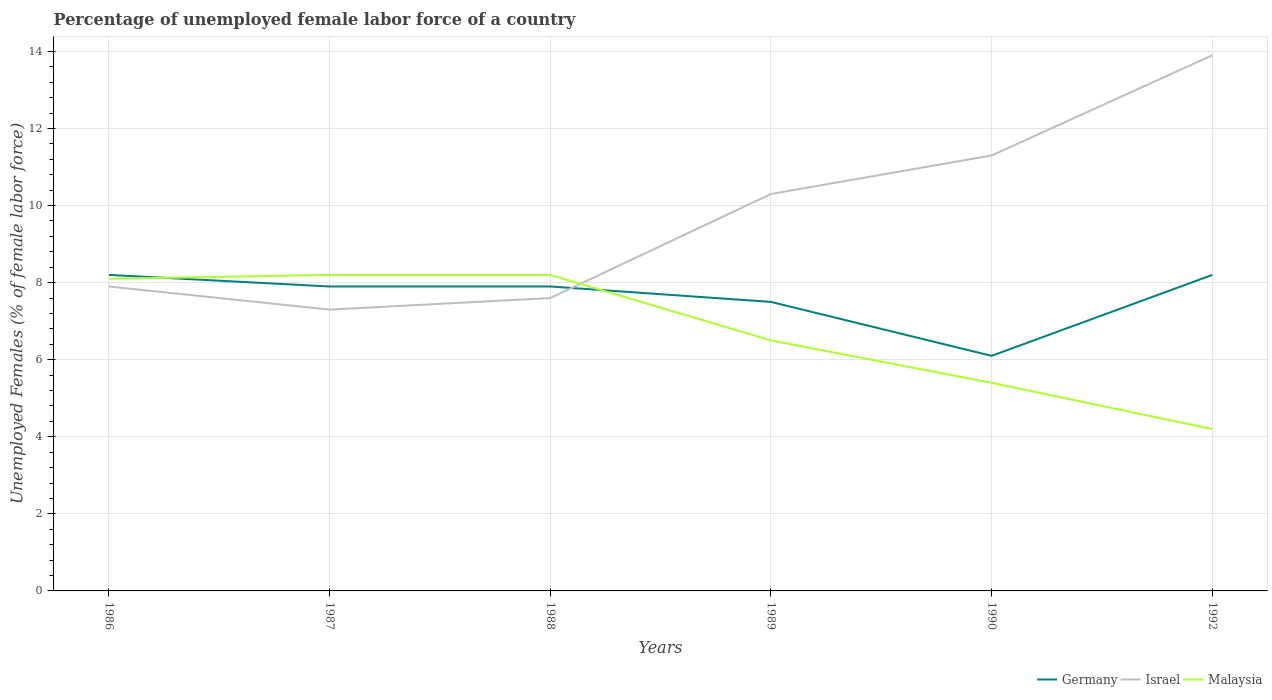Does the line corresponding to Israel intersect with the line corresponding to Germany?
Your response must be concise. Yes. Across all years, what is the maximum percentage of unemployed female labor force in Israel?
Make the answer very short. 7.3. In which year was the percentage of unemployed female labor force in Israel maximum?
Your answer should be compact. 1987. What is the total percentage of unemployed female labor force in Malaysia in the graph?
Provide a succinct answer. 1.7. What is the difference between the highest and the second highest percentage of unemployed female labor force in Israel?
Provide a succinct answer. 6.6. Is the percentage of unemployed female labor force in Israel strictly greater than the percentage of unemployed female labor force in Germany over the years?
Make the answer very short. No. How many lines are there?
Make the answer very short. 3. Are the values on the major ticks of Y-axis written in scientific E-notation?
Provide a short and direct response. No. Does the graph contain grids?
Your response must be concise. Yes. Where does the legend appear in the graph?
Offer a terse response. Bottom right. How many legend labels are there?
Give a very brief answer. 3. What is the title of the graph?
Your answer should be compact. Percentage of unemployed female labor force of a country. What is the label or title of the X-axis?
Ensure brevity in your answer.  Years. What is the label or title of the Y-axis?
Offer a terse response. Unemployed Females (% of female labor force). What is the Unemployed Females (% of female labor force) in Germany in 1986?
Offer a very short reply. 8.2. What is the Unemployed Females (% of female labor force) in Israel in 1986?
Your answer should be very brief. 7.9. What is the Unemployed Females (% of female labor force) in Malaysia in 1986?
Give a very brief answer. 8.1. What is the Unemployed Females (% of female labor force) in Germany in 1987?
Offer a very short reply. 7.9. What is the Unemployed Females (% of female labor force) in Israel in 1987?
Your answer should be very brief. 7.3. What is the Unemployed Females (% of female labor force) of Malaysia in 1987?
Your response must be concise. 8.2. What is the Unemployed Females (% of female labor force) of Germany in 1988?
Your response must be concise. 7.9. What is the Unemployed Females (% of female labor force) of Israel in 1988?
Provide a succinct answer. 7.6. What is the Unemployed Females (% of female labor force) of Malaysia in 1988?
Provide a succinct answer. 8.2. What is the Unemployed Females (% of female labor force) in Israel in 1989?
Provide a short and direct response. 10.3. What is the Unemployed Females (% of female labor force) of Germany in 1990?
Provide a succinct answer. 6.1. What is the Unemployed Females (% of female labor force) of Israel in 1990?
Keep it short and to the point. 11.3. What is the Unemployed Females (% of female labor force) in Malaysia in 1990?
Make the answer very short. 5.4. What is the Unemployed Females (% of female labor force) in Germany in 1992?
Give a very brief answer. 8.2. What is the Unemployed Females (% of female labor force) in Israel in 1992?
Ensure brevity in your answer.  13.9. What is the Unemployed Females (% of female labor force) of Malaysia in 1992?
Your answer should be compact. 4.2. Across all years, what is the maximum Unemployed Females (% of female labor force) of Germany?
Your response must be concise. 8.2. Across all years, what is the maximum Unemployed Females (% of female labor force) in Israel?
Your answer should be very brief. 13.9. Across all years, what is the maximum Unemployed Females (% of female labor force) of Malaysia?
Provide a succinct answer. 8.2. Across all years, what is the minimum Unemployed Females (% of female labor force) of Germany?
Offer a terse response. 6.1. Across all years, what is the minimum Unemployed Females (% of female labor force) of Israel?
Give a very brief answer. 7.3. Across all years, what is the minimum Unemployed Females (% of female labor force) in Malaysia?
Offer a very short reply. 4.2. What is the total Unemployed Females (% of female labor force) in Germany in the graph?
Your answer should be compact. 45.8. What is the total Unemployed Females (% of female labor force) of Israel in the graph?
Give a very brief answer. 58.3. What is the total Unemployed Females (% of female labor force) in Malaysia in the graph?
Your answer should be very brief. 40.6. What is the difference between the Unemployed Females (% of female labor force) in Germany in 1986 and that in 1987?
Make the answer very short. 0.3. What is the difference between the Unemployed Females (% of female labor force) of Israel in 1986 and that in 1987?
Your answer should be compact. 0.6. What is the difference between the Unemployed Females (% of female labor force) in Malaysia in 1986 and that in 1988?
Provide a short and direct response. -0.1. What is the difference between the Unemployed Females (% of female labor force) in Israel in 1986 and that in 1989?
Provide a short and direct response. -2.4. What is the difference between the Unemployed Females (% of female labor force) of Germany in 1986 and that in 1990?
Ensure brevity in your answer.  2.1. What is the difference between the Unemployed Females (% of female labor force) of Israel in 1986 and that in 1990?
Provide a short and direct response. -3.4. What is the difference between the Unemployed Females (% of female labor force) of Malaysia in 1986 and that in 1990?
Provide a short and direct response. 2.7. What is the difference between the Unemployed Females (% of female labor force) in Germany in 1986 and that in 1992?
Ensure brevity in your answer.  0. What is the difference between the Unemployed Females (% of female labor force) in Germany in 1987 and that in 1988?
Keep it short and to the point. 0. What is the difference between the Unemployed Females (% of female labor force) of Israel in 1987 and that in 1988?
Your response must be concise. -0.3. What is the difference between the Unemployed Females (% of female labor force) of Malaysia in 1987 and that in 1989?
Make the answer very short. 1.7. What is the difference between the Unemployed Females (% of female labor force) of Malaysia in 1987 and that in 1990?
Offer a terse response. 2.8. What is the difference between the Unemployed Females (% of female labor force) of Germany in 1987 and that in 1992?
Your answer should be compact. -0.3. What is the difference between the Unemployed Females (% of female labor force) of Malaysia in 1987 and that in 1992?
Give a very brief answer. 4. What is the difference between the Unemployed Females (% of female labor force) of Germany in 1988 and that in 1989?
Your answer should be very brief. 0.4. What is the difference between the Unemployed Females (% of female labor force) in Malaysia in 1988 and that in 1989?
Provide a succinct answer. 1.7. What is the difference between the Unemployed Females (% of female labor force) of Germany in 1988 and that in 1990?
Provide a succinct answer. 1.8. What is the difference between the Unemployed Females (% of female labor force) of Israel in 1988 and that in 1990?
Give a very brief answer. -3.7. What is the difference between the Unemployed Females (% of female labor force) of Malaysia in 1988 and that in 1990?
Provide a succinct answer. 2.8. What is the difference between the Unemployed Females (% of female labor force) in Germany in 1988 and that in 1992?
Give a very brief answer. -0.3. What is the difference between the Unemployed Females (% of female labor force) of Israel in 1988 and that in 1992?
Provide a succinct answer. -6.3. What is the difference between the Unemployed Females (% of female labor force) of Israel in 1989 and that in 1992?
Offer a terse response. -3.6. What is the difference between the Unemployed Females (% of female labor force) in Malaysia in 1989 and that in 1992?
Make the answer very short. 2.3. What is the difference between the Unemployed Females (% of female labor force) in Germany in 1990 and that in 1992?
Offer a very short reply. -2.1. What is the difference between the Unemployed Females (% of female labor force) in Israel in 1990 and that in 1992?
Ensure brevity in your answer.  -2.6. What is the difference between the Unemployed Females (% of female labor force) of Germany in 1986 and the Unemployed Females (% of female labor force) of Israel in 1987?
Make the answer very short. 0.9. What is the difference between the Unemployed Females (% of female labor force) in Germany in 1986 and the Unemployed Females (% of female labor force) in Malaysia in 1987?
Your response must be concise. 0. What is the difference between the Unemployed Females (% of female labor force) in Germany in 1986 and the Unemployed Females (% of female labor force) in Israel in 1988?
Offer a very short reply. 0.6. What is the difference between the Unemployed Females (% of female labor force) in Germany in 1986 and the Unemployed Females (% of female labor force) in Malaysia in 1988?
Make the answer very short. 0. What is the difference between the Unemployed Females (% of female labor force) in Israel in 1986 and the Unemployed Females (% of female labor force) in Malaysia in 1988?
Provide a succinct answer. -0.3. What is the difference between the Unemployed Females (% of female labor force) of Germany in 1986 and the Unemployed Females (% of female labor force) of Israel in 1989?
Your response must be concise. -2.1. What is the difference between the Unemployed Females (% of female labor force) in Germany in 1986 and the Unemployed Females (% of female labor force) in Israel in 1990?
Provide a short and direct response. -3.1. What is the difference between the Unemployed Females (% of female labor force) in Germany in 1986 and the Unemployed Females (% of female labor force) in Malaysia in 1990?
Make the answer very short. 2.8. What is the difference between the Unemployed Females (% of female labor force) of Israel in 1986 and the Unemployed Females (% of female labor force) of Malaysia in 1992?
Offer a terse response. 3.7. What is the difference between the Unemployed Females (% of female labor force) of Germany in 1987 and the Unemployed Females (% of female labor force) of Israel in 1988?
Your response must be concise. 0.3. What is the difference between the Unemployed Females (% of female labor force) in Israel in 1987 and the Unemployed Females (% of female labor force) in Malaysia in 1988?
Provide a succinct answer. -0.9. What is the difference between the Unemployed Females (% of female labor force) in Germany in 1987 and the Unemployed Females (% of female labor force) in Israel in 1989?
Provide a succinct answer. -2.4. What is the difference between the Unemployed Females (% of female labor force) of Israel in 1987 and the Unemployed Females (% of female labor force) of Malaysia in 1989?
Give a very brief answer. 0.8. What is the difference between the Unemployed Females (% of female labor force) in Germany in 1987 and the Unemployed Females (% of female labor force) in Israel in 1990?
Your response must be concise. -3.4. What is the difference between the Unemployed Females (% of female labor force) of Germany in 1987 and the Unemployed Females (% of female labor force) of Malaysia in 1992?
Make the answer very short. 3.7. What is the difference between the Unemployed Females (% of female labor force) of Israel in 1987 and the Unemployed Females (% of female labor force) of Malaysia in 1992?
Your response must be concise. 3.1. What is the difference between the Unemployed Females (% of female labor force) in Israel in 1988 and the Unemployed Females (% of female labor force) in Malaysia in 1990?
Provide a short and direct response. 2.2. What is the difference between the Unemployed Females (% of female labor force) of Germany in 1988 and the Unemployed Females (% of female labor force) of Israel in 1992?
Your answer should be compact. -6. What is the difference between the Unemployed Females (% of female labor force) in Germany in 1988 and the Unemployed Females (% of female labor force) in Malaysia in 1992?
Your response must be concise. 3.7. What is the difference between the Unemployed Females (% of female labor force) of Germany in 1989 and the Unemployed Females (% of female labor force) of Israel in 1990?
Keep it short and to the point. -3.8. What is the difference between the Unemployed Females (% of female labor force) of Israel in 1989 and the Unemployed Females (% of female labor force) of Malaysia in 1992?
Make the answer very short. 6.1. What is the difference between the Unemployed Females (% of female labor force) in Germany in 1990 and the Unemployed Females (% of female labor force) in Israel in 1992?
Offer a terse response. -7.8. What is the average Unemployed Females (% of female labor force) of Germany per year?
Offer a terse response. 7.63. What is the average Unemployed Females (% of female labor force) in Israel per year?
Give a very brief answer. 9.72. What is the average Unemployed Females (% of female labor force) of Malaysia per year?
Ensure brevity in your answer.  6.77. In the year 1986, what is the difference between the Unemployed Females (% of female labor force) of Germany and Unemployed Females (% of female labor force) of Israel?
Offer a very short reply. 0.3. In the year 1986, what is the difference between the Unemployed Females (% of female labor force) of Israel and Unemployed Females (% of female labor force) of Malaysia?
Keep it short and to the point. -0.2. In the year 1987, what is the difference between the Unemployed Females (% of female labor force) in Germany and Unemployed Females (% of female labor force) in Israel?
Provide a succinct answer. 0.6. In the year 1987, what is the difference between the Unemployed Females (% of female labor force) of Germany and Unemployed Females (% of female labor force) of Malaysia?
Your answer should be very brief. -0.3. In the year 1987, what is the difference between the Unemployed Females (% of female labor force) in Israel and Unemployed Females (% of female labor force) in Malaysia?
Make the answer very short. -0.9. In the year 1988, what is the difference between the Unemployed Females (% of female labor force) in Germany and Unemployed Females (% of female labor force) in Israel?
Provide a short and direct response. 0.3. In the year 1988, what is the difference between the Unemployed Females (% of female labor force) of Germany and Unemployed Females (% of female labor force) of Malaysia?
Make the answer very short. -0.3. In the year 1988, what is the difference between the Unemployed Females (% of female labor force) of Israel and Unemployed Females (% of female labor force) of Malaysia?
Keep it short and to the point. -0.6. In the year 1990, what is the difference between the Unemployed Females (% of female labor force) of Germany and Unemployed Females (% of female labor force) of Israel?
Make the answer very short. -5.2. In the year 1990, what is the difference between the Unemployed Females (% of female labor force) in Israel and Unemployed Females (% of female labor force) in Malaysia?
Ensure brevity in your answer.  5.9. In the year 1992, what is the difference between the Unemployed Females (% of female labor force) in Germany and Unemployed Females (% of female labor force) in Israel?
Offer a very short reply. -5.7. In the year 1992, what is the difference between the Unemployed Females (% of female labor force) in Germany and Unemployed Females (% of female labor force) in Malaysia?
Your answer should be very brief. 4. What is the ratio of the Unemployed Females (% of female labor force) of Germany in 1986 to that in 1987?
Ensure brevity in your answer.  1.04. What is the ratio of the Unemployed Females (% of female labor force) of Israel in 1986 to that in 1987?
Offer a very short reply. 1.08. What is the ratio of the Unemployed Females (% of female labor force) of Germany in 1986 to that in 1988?
Make the answer very short. 1.04. What is the ratio of the Unemployed Females (% of female labor force) of Israel in 1986 to that in 1988?
Give a very brief answer. 1.04. What is the ratio of the Unemployed Females (% of female labor force) in Malaysia in 1986 to that in 1988?
Offer a terse response. 0.99. What is the ratio of the Unemployed Females (% of female labor force) of Germany in 1986 to that in 1989?
Provide a succinct answer. 1.09. What is the ratio of the Unemployed Females (% of female labor force) in Israel in 1986 to that in 1989?
Keep it short and to the point. 0.77. What is the ratio of the Unemployed Females (% of female labor force) of Malaysia in 1986 to that in 1989?
Make the answer very short. 1.25. What is the ratio of the Unemployed Females (% of female labor force) of Germany in 1986 to that in 1990?
Make the answer very short. 1.34. What is the ratio of the Unemployed Females (% of female labor force) of Israel in 1986 to that in 1990?
Give a very brief answer. 0.7. What is the ratio of the Unemployed Females (% of female labor force) of Germany in 1986 to that in 1992?
Offer a terse response. 1. What is the ratio of the Unemployed Females (% of female labor force) in Israel in 1986 to that in 1992?
Your answer should be very brief. 0.57. What is the ratio of the Unemployed Females (% of female labor force) of Malaysia in 1986 to that in 1992?
Your response must be concise. 1.93. What is the ratio of the Unemployed Females (% of female labor force) of Germany in 1987 to that in 1988?
Your answer should be very brief. 1. What is the ratio of the Unemployed Females (% of female labor force) in Israel in 1987 to that in 1988?
Your answer should be very brief. 0.96. What is the ratio of the Unemployed Females (% of female labor force) in Malaysia in 1987 to that in 1988?
Provide a short and direct response. 1. What is the ratio of the Unemployed Females (% of female labor force) in Germany in 1987 to that in 1989?
Make the answer very short. 1.05. What is the ratio of the Unemployed Females (% of female labor force) of Israel in 1987 to that in 1989?
Offer a very short reply. 0.71. What is the ratio of the Unemployed Females (% of female labor force) in Malaysia in 1987 to that in 1989?
Make the answer very short. 1.26. What is the ratio of the Unemployed Females (% of female labor force) in Germany in 1987 to that in 1990?
Your answer should be very brief. 1.3. What is the ratio of the Unemployed Females (% of female labor force) of Israel in 1987 to that in 1990?
Your answer should be compact. 0.65. What is the ratio of the Unemployed Females (% of female labor force) of Malaysia in 1987 to that in 1990?
Your answer should be very brief. 1.52. What is the ratio of the Unemployed Females (% of female labor force) in Germany in 1987 to that in 1992?
Give a very brief answer. 0.96. What is the ratio of the Unemployed Females (% of female labor force) of Israel in 1987 to that in 1992?
Your answer should be very brief. 0.53. What is the ratio of the Unemployed Females (% of female labor force) of Malaysia in 1987 to that in 1992?
Your response must be concise. 1.95. What is the ratio of the Unemployed Females (% of female labor force) in Germany in 1988 to that in 1989?
Provide a short and direct response. 1.05. What is the ratio of the Unemployed Females (% of female labor force) of Israel in 1988 to that in 1989?
Your answer should be very brief. 0.74. What is the ratio of the Unemployed Females (% of female labor force) in Malaysia in 1988 to that in 1989?
Your answer should be compact. 1.26. What is the ratio of the Unemployed Females (% of female labor force) in Germany in 1988 to that in 1990?
Give a very brief answer. 1.3. What is the ratio of the Unemployed Females (% of female labor force) in Israel in 1988 to that in 1990?
Offer a terse response. 0.67. What is the ratio of the Unemployed Females (% of female labor force) of Malaysia in 1988 to that in 1990?
Make the answer very short. 1.52. What is the ratio of the Unemployed Females (% of female labor force) in Germany in 1988 to that in 1992?
Offer a terse response. 0.96. What is the ratio of the Unemployed Females (% of female labor force) in Israel in 1988 to that in 1992?
Ensure brevity in your answer.  0.55. What is the ratio of the Unemployed Females (% of female labor force) of Malaysia in 1988 to that in 1992?
Your response must be concise. 1.95. What is the ratio of the Unemployed Females (% of female labor force) of Germany in 1989 to that in 1990?
Your response must be concise. 1.23. What is the ratio of the Unemployed Females (% of female labor force) in Israel in 1989 to that in 1990?
Make the answer very short. 0.91. What is the ratio of the Unemployed Females (% of female labor force) of Malaysia in 1989 to that in 1990?
Offer a very short reply. 1.2. What is the ratio of the Unemployed Females (% of female labor force) in Germany in 1989 to that in 1992?
Provide a succinct answer. 0.91. What is the ratio of the Unemployed Females (% of female labor force) in Israel in 1989 to that in 1992?
Give a very brief answer. 0.74. What is the ratio of the Unemployed Females (% of female labor force) in Malaysia in 1989 to that in 1992?
Your response must be concise. 1.55. What is the ratio of the Unemployed Females (% of female labor force) of Germany in 1990 to that in 1992?
Give a very brief answer. 0.74. What is the ratio of the Unemployed Females (% of female labor force) in Israel in 1990 to that in 1992?
Provide a succinct answer. 0.81. What is the ratio of the Unemployed Females (% of female labor force) in Malaysia in 1990 to that in 1992?
Provide a short and direct response. 1.29. What is the difference between the highest and the second highest Unemployed Females (% of female labor force) in Israel?
Your response must be concise. 2.6. What is the difference between the highest and the second highest Unemployed Females (% of female labor force) in Malaysia?
Give a very brief answer. 0. What is the difference between the highest and the lowest Unemployed Females (% of female labor force) of Germany?
Offer a terse response. 2.1. What is the difference between the highest and the lowest Unemployed Females (% of female labor force) of Malaysia?
Your answer should be compact. 4. 